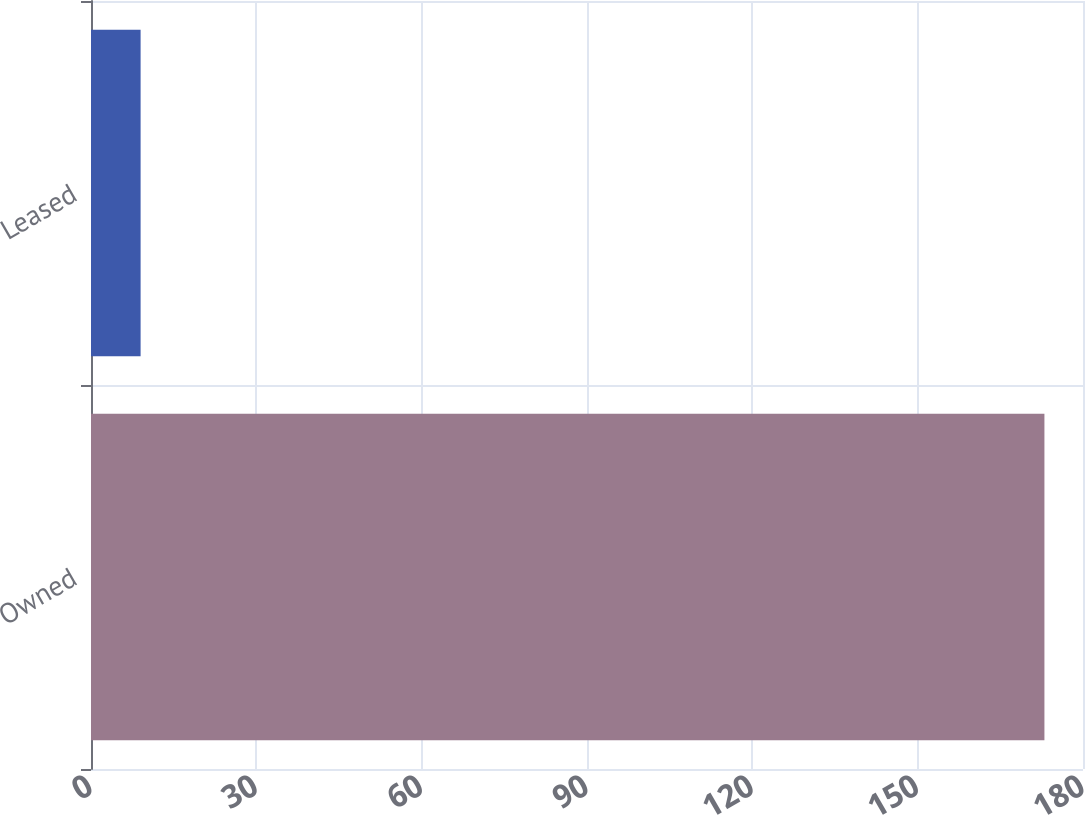<chart> <loc_0><loc_0><loc_500><loc_500><bar_chart><fcel>Owned<fcel>Leased<nl><fcel>173<fcel>9<nl></chart> 